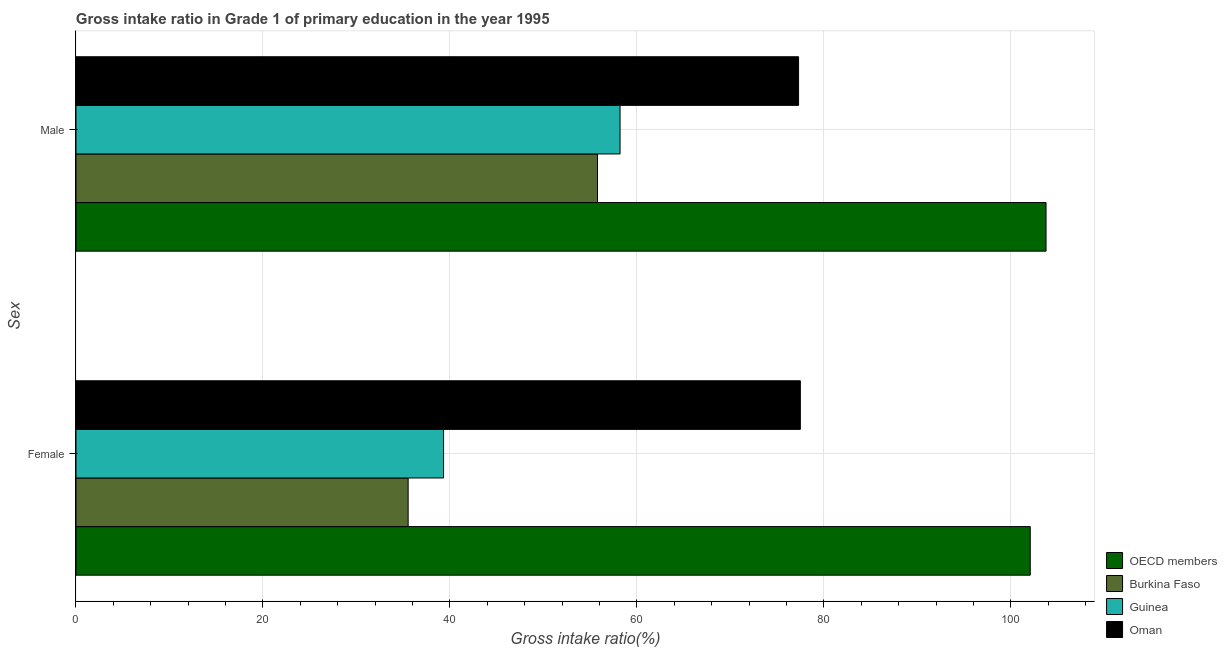How many groups of bars are there?
Keep it short and to the point. 2. Are the number of bars on each tick of the Y-axis equal?
Your response must be concise. Yes. How many bars are there on the 1st tick from the top?
Give a very brief answer. 4. How many bars are there on the 1st tick from the bottom?
Keep it short and to the point. 4. What is the label of the 2nd group of bars from the top?
Ensure brevity in your answer.  Female. What is the gross intake ratio(male) in Burkina Faso?
Offer a very short reply. 55.78. Across all countries, what is the maximum gross intake ratio(female)?
Offer a terse response. 102.07. Across all countries, what is the minimum gross intake ratio(male)?
Your response must be concise. 55.78. In which country was the gross intake ratio(male) minimum?
Offer a terse response. Burkina Faso. What is the total gross intake ratio(female) in the graph?
Your answer should be very brief. 254.39. What is the difference between the gross intake ratio(female) in Oman and that in OECD members?
Ensure brevity in your answer.  -24.59. What is the difference between the gross intake ratio(female) in Burkina Faso and the gross intake ratio(male) in Guinea?
Keep it short and to the point. -22.67. What is the average gross intake ratio(male) per country?
Keep it short and to the point. 73.76. What is the difference between the gross intake ratio(male) and gross intake ratio(female) in Guinea?
Keep it short and to the point. 18.88. In how many countries, is the gross intake ratio(male) greater than 40 %?
Make the answer very short. 4. What is the ratio of the gross intake ratio(male) in Guinea to that in Burkina Faso?
Offer a very short reply. 1.04. Is the gross intake ratio(female) in Guinea less than that in OECD members?
Provide a short and direct response. Yes. In how many countries, is the gross intake ratio(male) greater than the average gross intake ratio(male) taken over all countries?
Ensure brevity in your answer.  2. What does the 3rd bar from the top in Female represents?
Your answer should be compact. Burkina Faso. What does the 3rd bar from the bottom in Female represents?
Give a very brief answer. Guinea. How many bars are there?
Your answer should be compact. 8. Are all the bars in the graph horizontal?
Keep it short and to the point. Yes. How many countries are there in the graph?
Ensure brevity in your answer.  4. What is the difference between two consecutive major ticks on the X-axis?
Offer a terse response. 20. Are the values on the major ticks of X-axis written in scientific E-notation?
Give a very brief answer. No. How many legend labels are there?
Provide a short and direct response. 4. How are the legend labels stacked?
Keep it short and to the point. Vertical. What is the title of the graph?
Your answer should be compact. Gross intake ratio in Grade 1 of primary education in the year 1995. Does "Mali" appear as one of the legend labels in the graph?
Keep it short and to the point. No. What is the label or title of the X-axis?
Keep it short and to the point. Gross intake ratio(%). What is the label or title of the Y-axis?
Your answer should be compact. Sex. What is the Gross intake ratio(%) of OECD members in Female?
Ensure brevity in your answer.  102.07. What is the Gross intake ratio(%) in Burkina Faso in Female?
Provide a short and direct response. 35.53. What is the Gross intake ratio(%) in Guinea in Female?
Provide a succinct answer. 39.32. What is the Gross intake ratio(%) of Oman in Female?
Give a very brief answer. 77.48. What is the Gross intake ratio(%) of OECD members in Male?
Your answer should be very brief. 103.76. What is the Gross intake ratio(%) of Burkina Faso in Male?
Offer a terse response. 55.78. What is the Gross intake ratio(%) in Guinea in Male?
Keep it short and to the point. 58.19. What is the Gross intake ratio(%) in Oman in Male?
Provide a succinct answer. 77.29. Across all Sex, what is the maximum Gross intake ratio(%) in OECD members?
Offer a very short reply. 103.76. Across all Sex, what is the maximum Gross intake ratio(%) of Burkina Faso?
Your response must be concise. 55.78. Across all Sex, what is the maximum Gross intake ratio(%) of Guinea?
Ensure brevity in your answer.  58.19. Across all Sex, what is the maximum Gross intake ratio(%) in Oman?
Keep it short and to the point. 77.48. Across all Sex, what is the minimum Gross intake ratio(%) of OECD members?
Offer a terse response. 102.07. Across all Sex, what is the minimum Gross intake ratio(%) of Burkina Faso?
Keep it short and to the point. 35.53. Across all Sex, what is the minimum Gross intake ratio(%) in Guinea?
Your answer should be very brief. 39.32. Across all Sex, what is the minimum Gross intake ratio(%) of Oman?
Provide a succinct answer. 77.29. What is the total Gross intake ratio(%) of OECD members in the graph?
Offer a terse response. 205.83. What is the total Gross intake ratio(%) of Burkina Faso in the graph?
Your answer should be compact. 91.31. What is the total Gross intake ratio(%) in Guinea in the graph?
Your answer should be compact. 97.51. What is the total Gross intake ratio(%) in Oman in the graph?
Offer a very short reply. 154.77. What is the difference between the Gross intake ratio(%) of OECD members in Female and that in Male?
Your response must be concise. -1.69. What is the difference between the Gross intake ratio(%) in Burkina Faso in Female and that in Male?
Keep it short and to the point. -20.25. What is the difference between the Gross intake ratio(%) of Guinea in Female and that in Male?
Provide a succinct answer. -18.88. What is the difference between the Gross intake ratio(%) in Oman in Female and that in Male?
Your answer should be very brief. 0.19. What is the difference between the Gross intake ratio(%) in OECD members in Female and the Gross intake ratio(%) in Burkina Faso in Male?
Your answer should be compact. 46.29. What is the difference between the Gross intake ratio(%) of OECD members in Female and the Gross intake ratio(%) of Guinea in Male?
Your response must be concise. 43.88. What is the difference between the Gross intake ratio(%) of OECD members in Female and the Gross intake ratio(%) of Oman in Male?
Your answer should be compact. 24.78. What is the difference between the Gross intake ratio(%) in Burkina Faso in Female and the Gross intake ratio(%) in Guinea in Male?
Ensure brevity in your answer.  -22.67. What is the difference between the Gross intake ratio(%) of Burkina Faso in Female and the Gross intake ratio(%) of Oman in Male?
Offer a very short reply. -41.76. What is the difference between the Gross intake ratio(%) of Guinea in Female and the Gross intake ratio(%) of Oman in Male?
Your answer should be compact. -37.97. What is the average Gross intake ratio(%) of OECD members per Sex?
Provide a short and direct response. 102.91. What is the average Gross intake ratio(%) in Burkina Faso per Sex?
Ensure brevity in your answer.  45.65. What is the average Gross intake ratio(%) of Guinea per Sex?
Keep it short and to the point. 48.76. What is the average Gross intake ratio(%) of Oman per Sex?
Keep it short and to the point. 77.38. What is the difference between the Gross intake ratio(%) in OECD members and Gross intake ratio(%) in Burkina Faso in Female?
Provide a succinct answer. 66.54. What is the difference between the Gross intake ratio(%) of OECD members and Gross intake ratio(%) of Guinea in Female?
Your answer should be very brief. 62.75. What is the difference between the Gross intake ratio(%) in OECD members and Gross intake ratio(%) in Oman in Female?
Make the answer very short. 24.59. What is the difference between the Gross intake ratio(%) in Burkina Faso and Gross intake ratio(%) in Guinea in Female?
Your response must be concise. -3.79. What is the difference between the Gross intake ratio(%) of Burkina Faso and Gross intake ratio(%) of Oman in Female?
Offer a terse response. -41.95. What is the difference between the Gross intake ratio(%) in Guinea and Gross intake ratio(%) in Oman in Female?
Offer a very short reply. -38.16. What is the difference between the Gross intake ratio(%) in OECD members and Gross intake ratio(%) in Burkina Faso in Male?
Provide a succinct answer. 47.98. What is the difference between the Gross intake ratio(%) in OECD members and Gross intake ratio(%) in Guinea in Male?
Keep it short and to the point. 45.56. What is the difference between the Gross intake ratio(%) in OECD members and Gross intake ratio(%) in Oman in Male?
Provide a short and direct response. 26.47. What is the difference between the Gross intake ratio(%) of Burkina Faso and Gross intake ratio(%) of Guinea in Male?
Offer a terse response. -2.42. What is the difference between the Gross intake ratio(%) of Burkina Faso and Gross intake ratio(%) of Oman in Male?
Give a very brief answer. -21.51. What is the difference between the Gross intake ratio(%) of Guinea and Gross intake ratio(%) of Oman in Male?
Offer a very short reply. -19.09. What is the ratio of the Gross intake ratio(%) of OECD members in Female to that in Male?
Provide a short and direct response. 0.98. What is the ratio of the Gross intake ratio(%) in Burkina Faso in Female to that in Male?
Give a very brief answer. 0.64. What is the ratio of the Gross intake ratio(%) of Guinea in Female to that in Male?
Give a very brief answer. 0.68. What is the difference between the highest and the second highest Gross intake ratio(%) of OECD members?
Offer a terse response. 1.69. What is the difference between the highest and the second highest Gross intake ratio(%) in Burkina Faso?
Offer a terse response. 20.25. What is the difference between the highest and the second highest Gross intake ratio(%) in Guinea?
Make the answer very short. 18.88. What is the difference between the highest and the second highest Gross intake ratio(%) of Oman?
Ensure brevity in your answer.  0.19. What is the difference between the highest and the lowest Gross intake ratio(%) of OECD members?
Offer a terse response. 1.69. What is the difference between the highest and the lowest Gross intake ratio(%) of Burkina Faso?
Provide a succinct answer. 20.25. What is the difference between the highest and the lowest Gross intake ratio(%) of Guinea?
Keep it short and to the point. 18.88. What is the difference between the highest and the lowest Gross intake ratio(%) in Oman?
Make the answer very short. 0.19. 